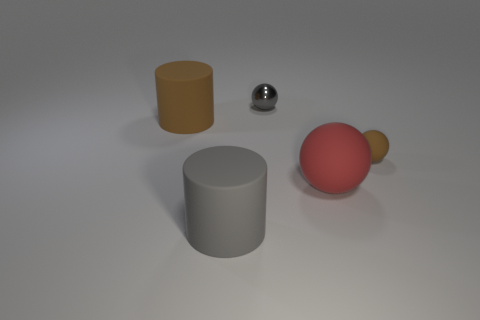What size is the brown rubber object that is left of the gray matte object?
Keep it short and to the point. Large. What shape is the big matte thing that is right of the brown matte cylinder and behind the gray cylinder?
Your answer should be compact. Sphere. What is the size of the gray object that is the same shape as the small brown object?
Keep it short and to the point. Small. What number of tiny red spheres have the same material as the big red thing?
Offer a very short reply. 0. Do the shiny ball and the large object in front of the red ball have the same color?
Give a very brief answer. Yes. Is the number of big red balls greater than the number of matte cylinders?
Make the answer very short. No. The large matte ball has what color?
Keep it short and to the point. Red. There is a tiny sphere right of the large red object; does it have the same color as the small metallic ball?
Your answer should be compact. No. There is a large object that is the same color as the tiny matte ball; what material is it?
Ensure brevity in your answer.  Rubber. What number of shiny objects have the same color as the big ball?
Your answer should be compact. 0. 